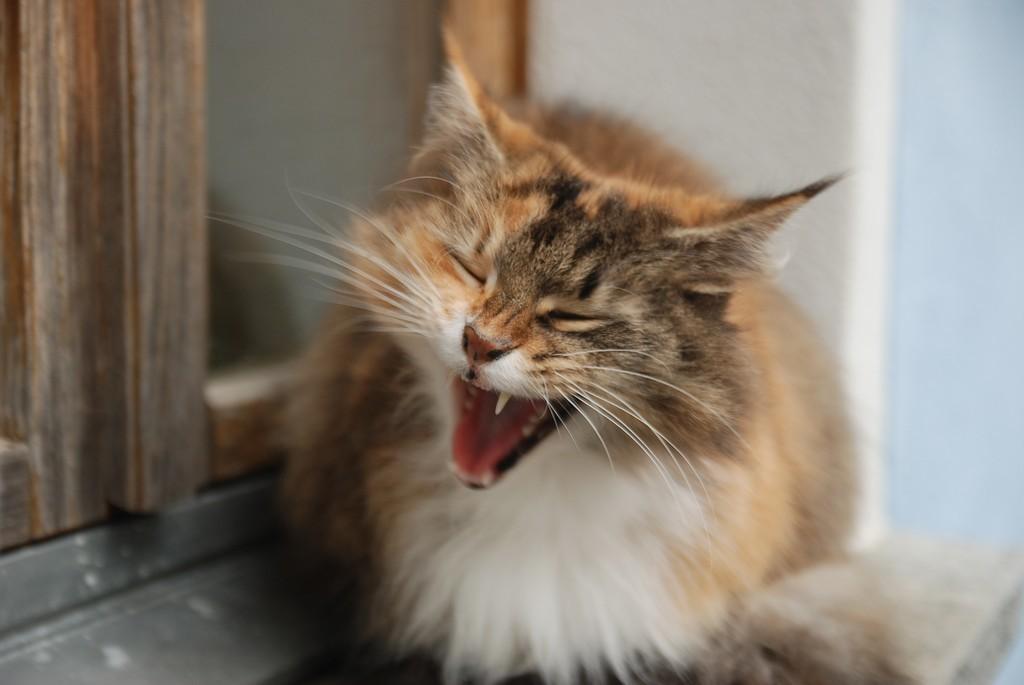Could you give a brief overview of what you see in this image? We can see a cat is sitting on a platform at the window doors and this is the wall. 